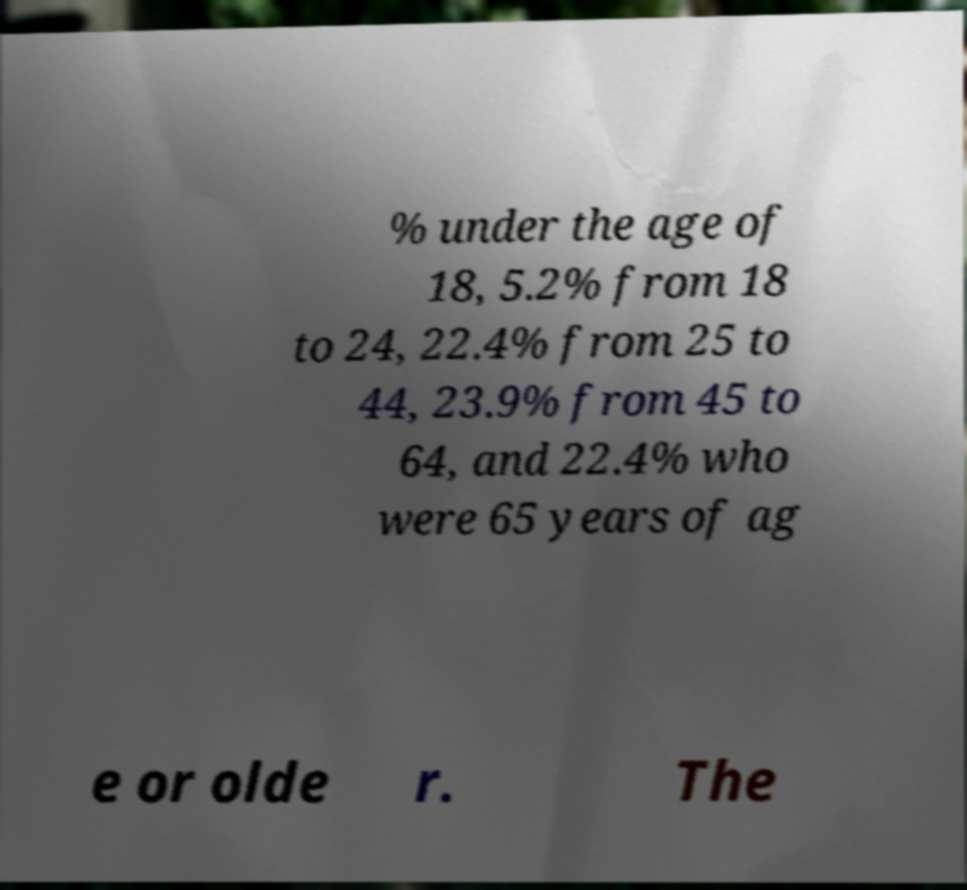There's text embedded in this image that I need extracted. Can you transcribe it verbatim? % under the age of 18, 5.2% from 18 to 24, 22.4% from 25 to 44, 23.9% from 45 to 64, and 22.4% who were 65 years of ag e or olde r. The 